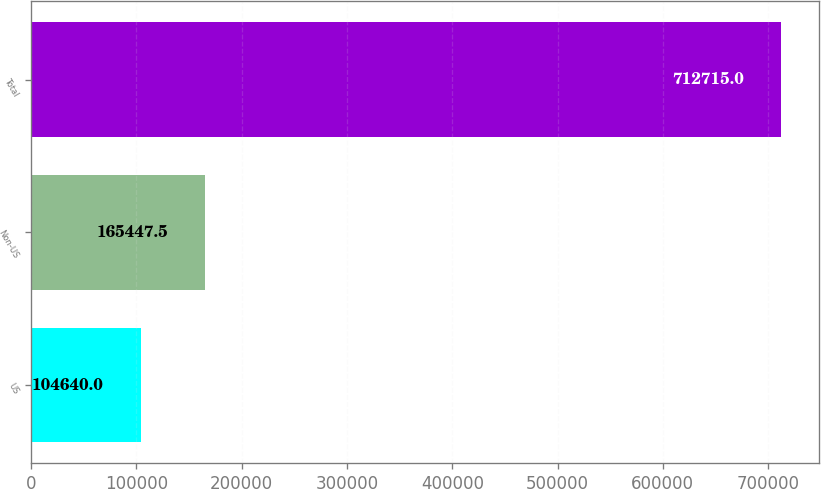<chart> <loc_0><loc_0><loc_500><loc_500><bar_chart><fcel>US<fcel>Non-US<fcel>Total<nl><fcel>104640<fcel>165448<fcel>712715<nl></chart> 